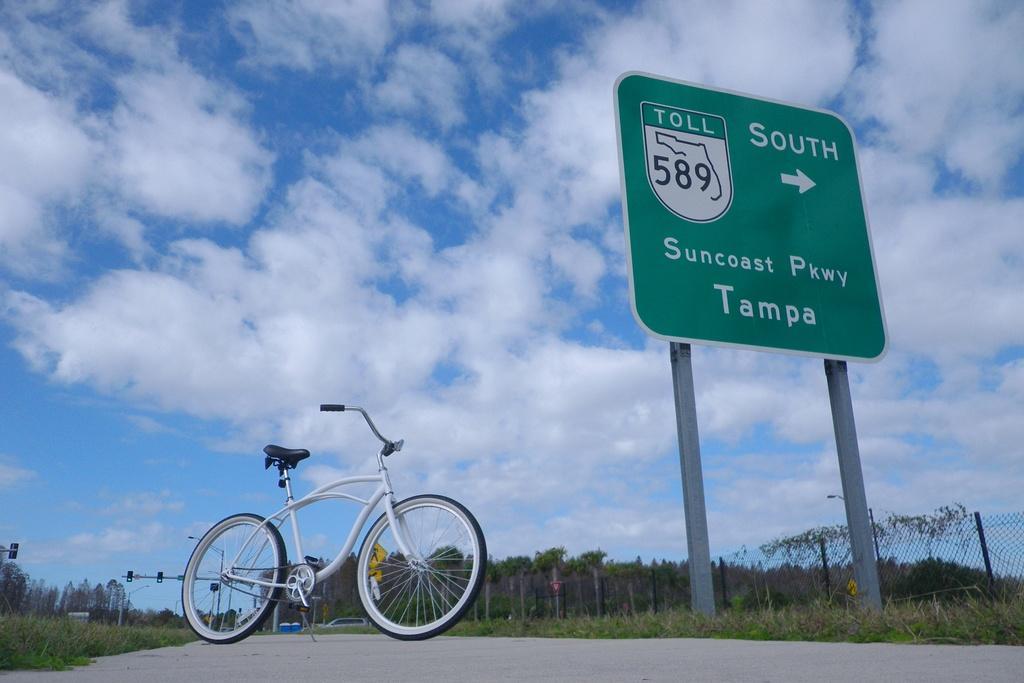Describe this image in one or two sentences. In this picture we can see board on poles, bicycle on the road, grass and fence. In the background of the image we can see traffic signals, light and board on poles, trees and sky with clouds. 